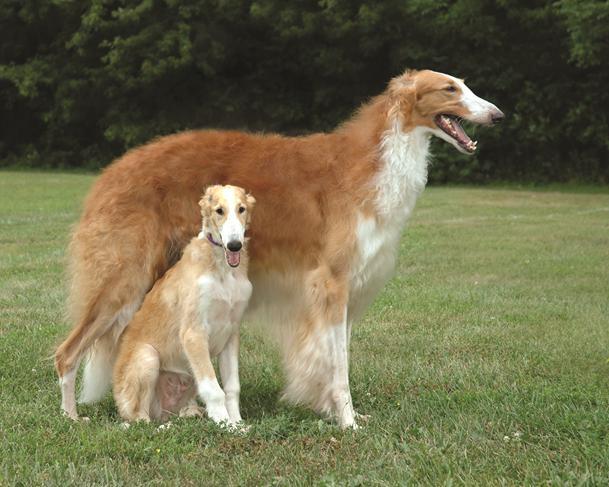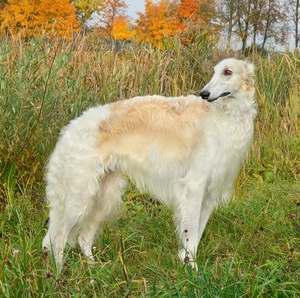The first image is the image on the left, the second image is the image on the right. Considering the images on both sides, is "Exactly three dogs are shown in grassy outdoor settings." valid? Answer yes or no. Yes. 